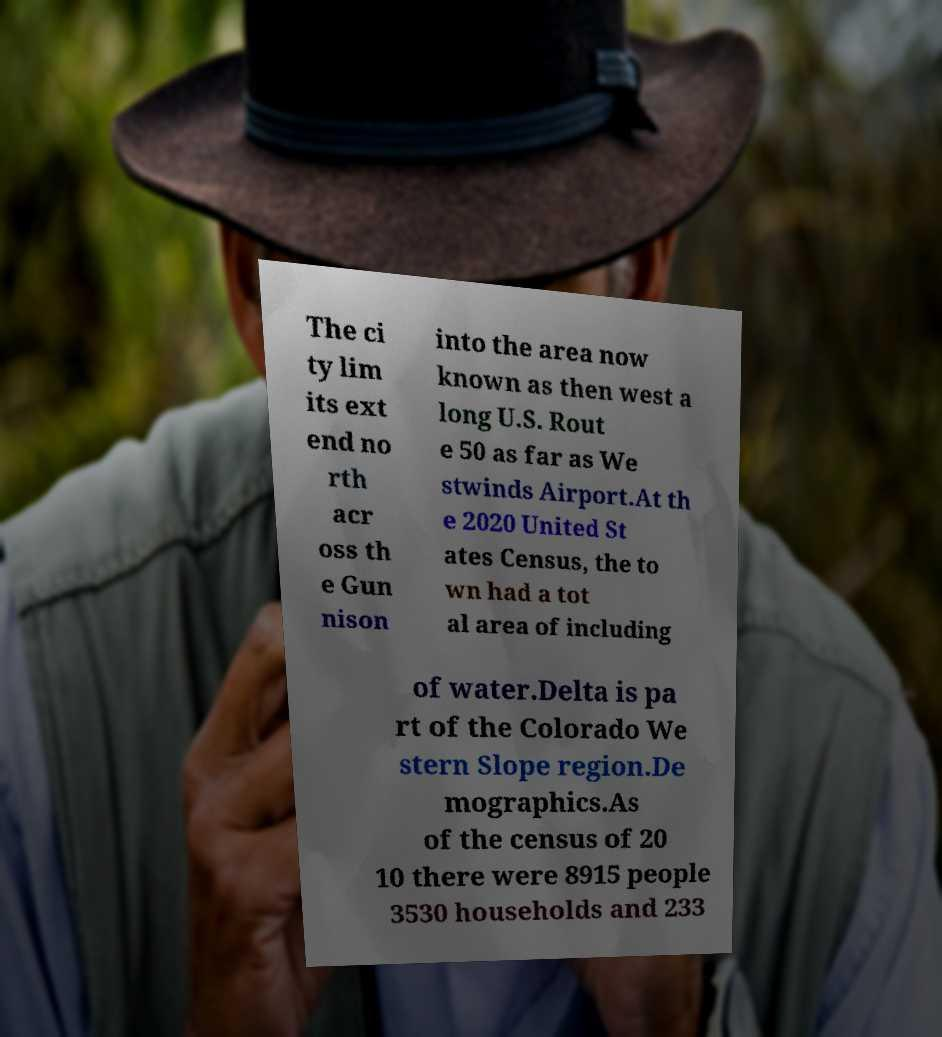There's text embedded in this image that I need extracted. Can you transcribe it verbatim? The ci ty lim its ext end no rth acr oss th e Gun nison into the area now known as then west a long U.S. Rout e 50 as far as We stwinds Airport.At th e 2020 United St ates Census, the to wn had a tot al area of including of water.Delta is pa rt of the Colorado We stern Slope region.De mographics.As of the census of 20 10 there were 8915 people 3530 households and 233 